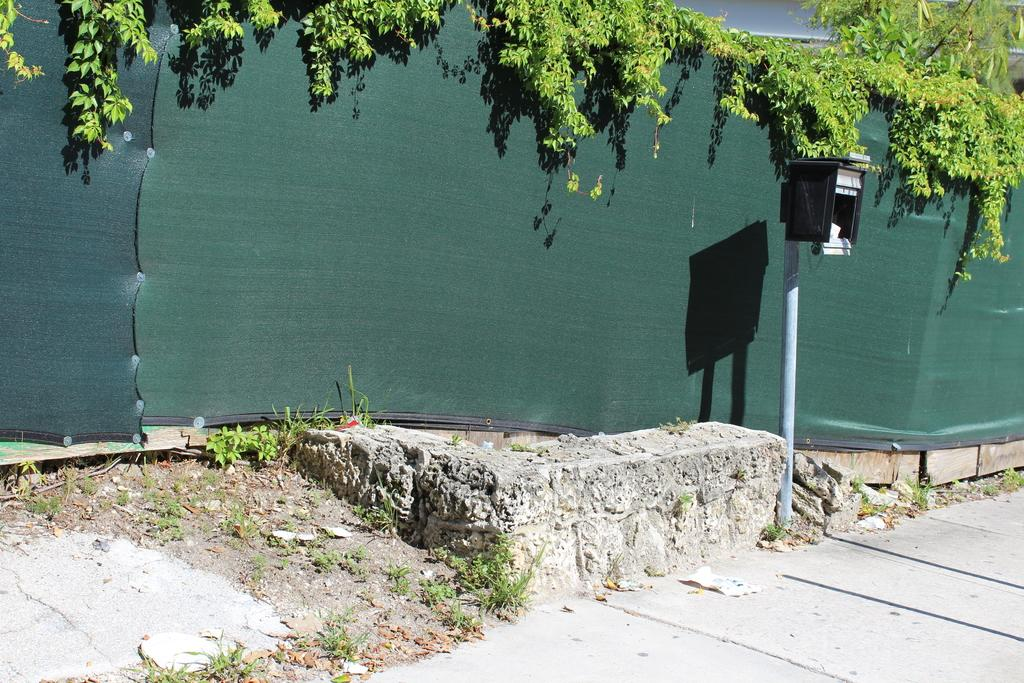What type of path is visible in the image? There is a walkway in the image. What object can be seen standing upright in the image? There is a pole in the image. What color is the wall visible in the background of the image? The wall in the background of the image is green. Can you see any matches being lit on the pole in the image? There are no matches present in the image, and the pole is not being used for lighting any matches. Is there a club visible in the image? There is no club present in the image; only a walkway, a pole, and a green wall are mentioned. 